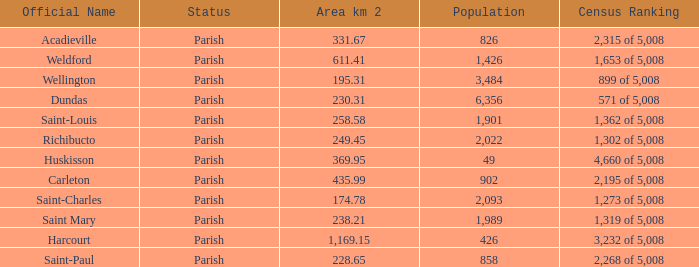For Saint-Paul parish, if it has an area of over 228.65 kilometers how many people live there? 0.0. 